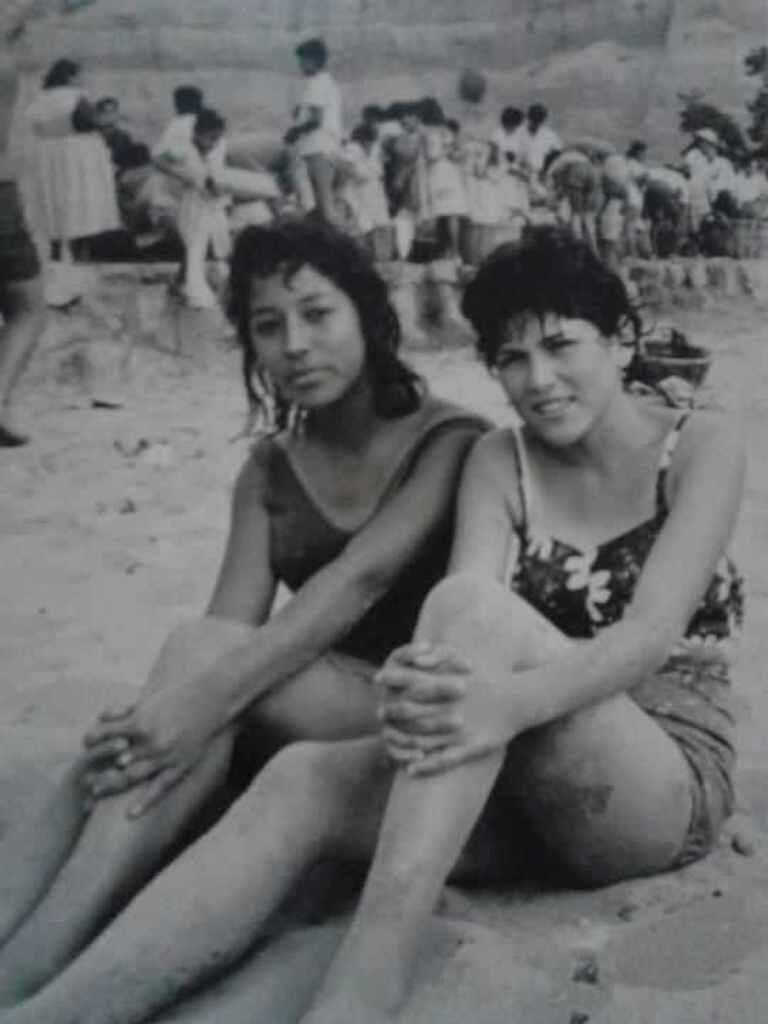How would you summarize this image in a sentence or two? This image consists of many people. At the front, there are two women sitting on the sand. At the bottom, there is sand. In the background, there are many people. 